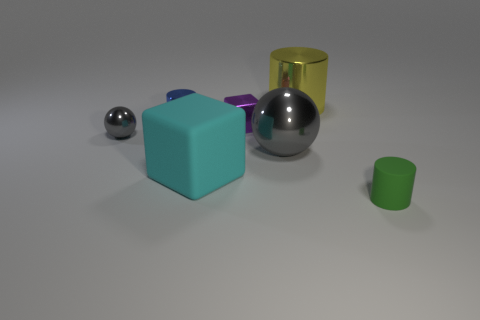There is a small cylinder that is made of the same material as the large gray ball; what is its color?
Give a very brief answer. Blue. What number of things are either small things that are to the left of the large yellow cylinder or shiny cylinders right of the metal cube?
Offer a very short reply. 4. There is a matte object left of the tiny green thing; is it the same size as the sphere right of the tiny blue thing?
Offer a terse response. Yes. What color is the large object that is the same shape as the small purple shiny thing?
Your answer should be compact. Cyan. Is there anything else that has the same shape as the yellow object?
Your response must be concise. Yes. Are there more big yellow metallic objects in front of the cyan cube than tiny rubber objects that are behind the big cylinder?
Give a very brief answer. No. There is a sphere that is right of the block behind the gray metallic sphere on the left side of the tiny cube; what is its size?
Ensure brevity in your answer.  Large. Does the tiny purple cube have the same material as the cylinder in front of the cyan thing?
Your response must be concise. No. Does the tiny gray shiny thing have the same shape as the blue metal object?
Provide a short and direct response. No. What number of other objects are there of the same material as the yellow cylinder?
Make the answer very short. 4. 